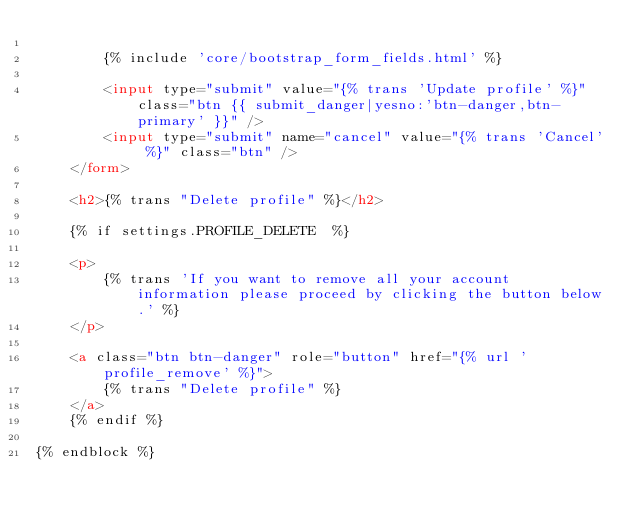<code> <loc_0><loc_0><loc_500><loc_500><_HTML_>
        {% include 'core/bootstrap_form_fields.html' %}

        <input type="submit" value="{% trans 'Update profile' %}" class="btn {{ submit_danger|yesno:'btn-danger,btn-primary' }}" />
        <input type="submit" name="cancel" value="{% trans 'Cancel' %}" class="btn" />
    </form>

    <h2>{% trans "Delete profile" %}</h2>

    {% if settings.PROFILE_DELETE  %}

    <p>
        {% trans 'If you want to remove all your account information please proceed by clicking the button below.' %}
    </p>

    <a class="btn btn-danger" role="button" href="{% url 'profile_remove' %}">
        {% trans "Delete profile" %}
    </a>
    {% endif %}

{% endblock %}
</code> 